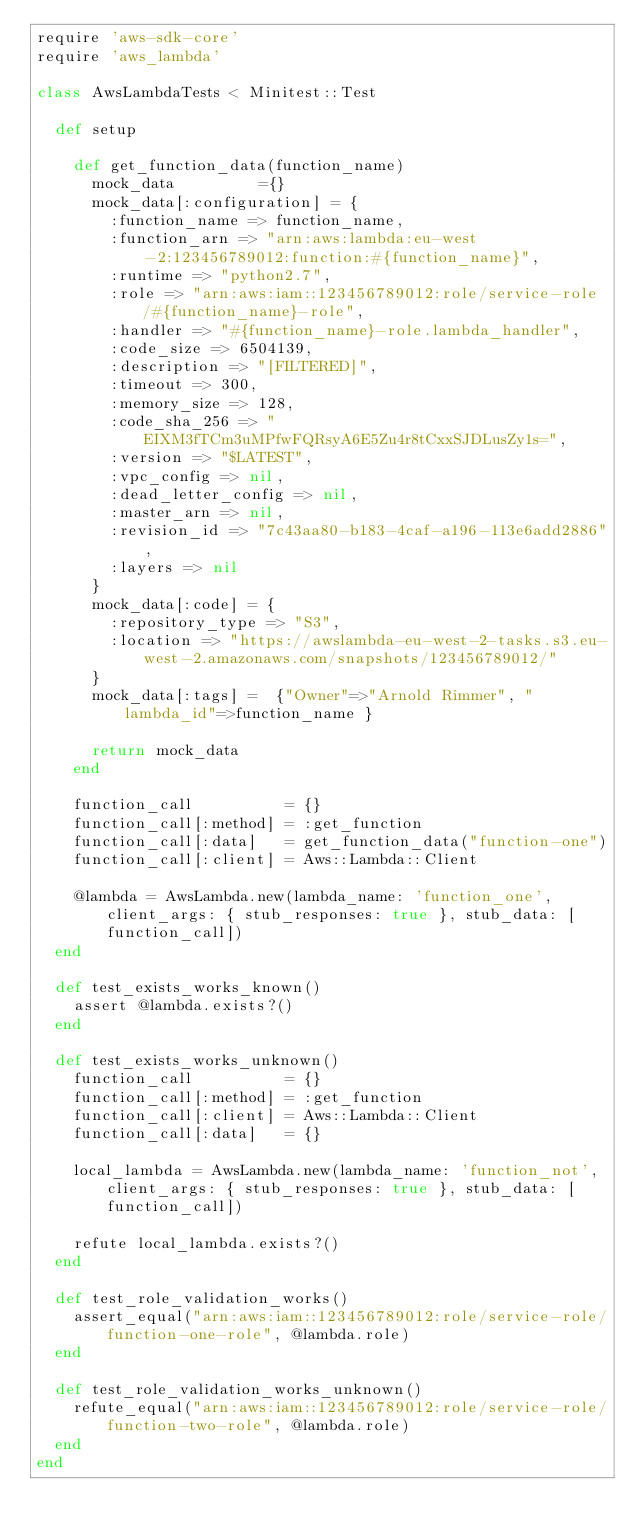<code> <loc_0><loc_0><loc_500><loc_500><_Ruby_>require 'aws-sdk-core'
require 'aws_lambda'

class AwsLambdaTests < Minitest::Test

  def setup

    def get_function_data(function_name)
      mock_data         ={}
      mock_data[:configuration] = {
        :function_name => function_name,
        :function_arn => "arn:aws:lambda:eu-west-2:123456789012:function:#{function_name}",
        :runtime => "python2.7",
        :role => "arn:aws:iam::123456789012:role/service-role/#{function_name}-role",
        :handler => "#{function_name}-role.lambda_handler",
        :code_size => 6504139,
        :description => "[FILTERED]",
        :timeout => 300,
        :memory_size => 128,
        :code_sha_256 => "EIXM3fTCm3uMPfwFQRsyA6E5Zu4r8tCxxSJDLusZy1s=",
        :version => "$LATEST",
        :vpc_config => nil,
        :dead_letter_config => nil,
        :master_arn => nil,
        :revision_id => "7c43aa80-b183-4caf-a196-113e6add2886",
        :layers => nil
      }
      mock_data[:code] = {
        :repository_type => "S3",
        :location => "https://awslambda-eu-west-2-tasks.s3.eu-west-2.amazonaws.com/snapshots/123456789012/"
      }
      mock_data[:tags] =  {"Owner"=>"Arnold Rimmer", "lambda_id"=>function_name }
  
      return mock_data
    end

    function_call          = {}
    function_call[:method] = :get_function
    function_call[:data]   = get_function_data("function-one") 
    function_call[:client] = Aws::Lambda::Client

    @lambda = AwsLambda.new(lambda_name: 'function_one', client_args: { stub_responses: true }, stub_data: [function_call])
  end

  def test_exists_works_known()
    assert @lambda.exists?()
  end

  def test_exists_works_unknown()
    function_call          = {}
    function_call[:method] = :get_function
    function_call[:client] = Aws::Lambda::Client
    function_call[:data]   = {}

    local_lambda = AwsLambda.new(lambda_name: 'function_not', client_args: { stub_responses: true }, stub_data: [function_call])

    refute local_lambda.exists?()
  end

  def test_role_validation_works()
    assert_equal("arn:aws:iam::123456789012:role/service-role/function-one-role", @lambda.role)
  end

  def test_role_validation_works_unknown()
    refute_equal("arn:aws:iam::123456789012:role/service-role/function-two-role", @lambda.role)
  end
end</code> 